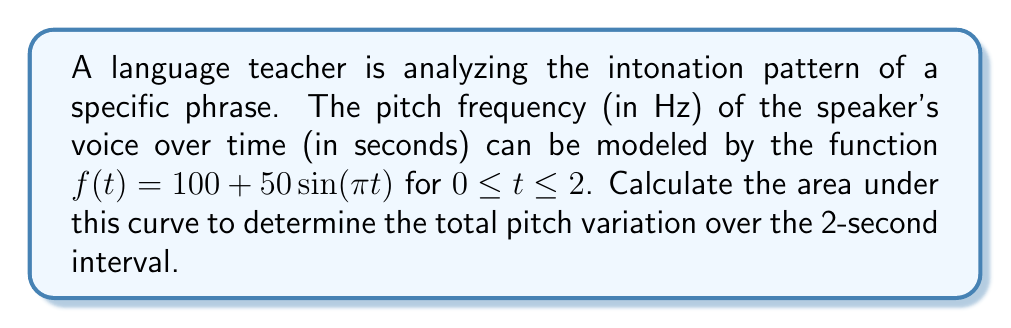Can you solve this math problem? To find the area under the curve, we need to calculate the definite integral of the function $f(t)$ from $t=0$ to $t=2$. Let's break this down step-by-step:

1) The function is $f(t) = 100 + 50\sin(\pi t)$

2) We need to integrate this function from 0 to 2:

   $$\int_0^2 (100 + 50\sin(\pi t)) dt$$

3) We can separate this into two integrals:

   $$\int_0^2 100 dt + \int_0^2 50\sin(\pi t) dt$$

4) For the first integral:
   $$\int_0^2 100 dt = 100t \bigg|_0^2 = 200 - 0 = 200$$

5) For the second integral, we use the substitution method:
   Let $u = \pi t$, then $du = \pi dt$, or $dt = \frac{1}{\pi}du$
   When $t = 0$, $u = 0$; when $t = 2$, $u = 2\pi$

   $$\int_0^2 50\sin(\pi t) dt = \frac{50}{\pi}\int_0^{2\pi} \sin(u) du$$

6) We know that $\int \sin(u) du = -\cos(u) + C$, so:

   $$\frac{50}{\pi}[-\cos(u)]_0^{2\pi} = \frac{50}{\pi}[-\cos(2\pi) + \cos(0)] = \frac{50}{\pi}[-1 + 1] = 0$$

7) Adding the results from steps 4 and 6:

   $200 + 0 = 200$

Therefore, the total area under the curve is 200 Hz·s.
Answer: 200 Hz·s 